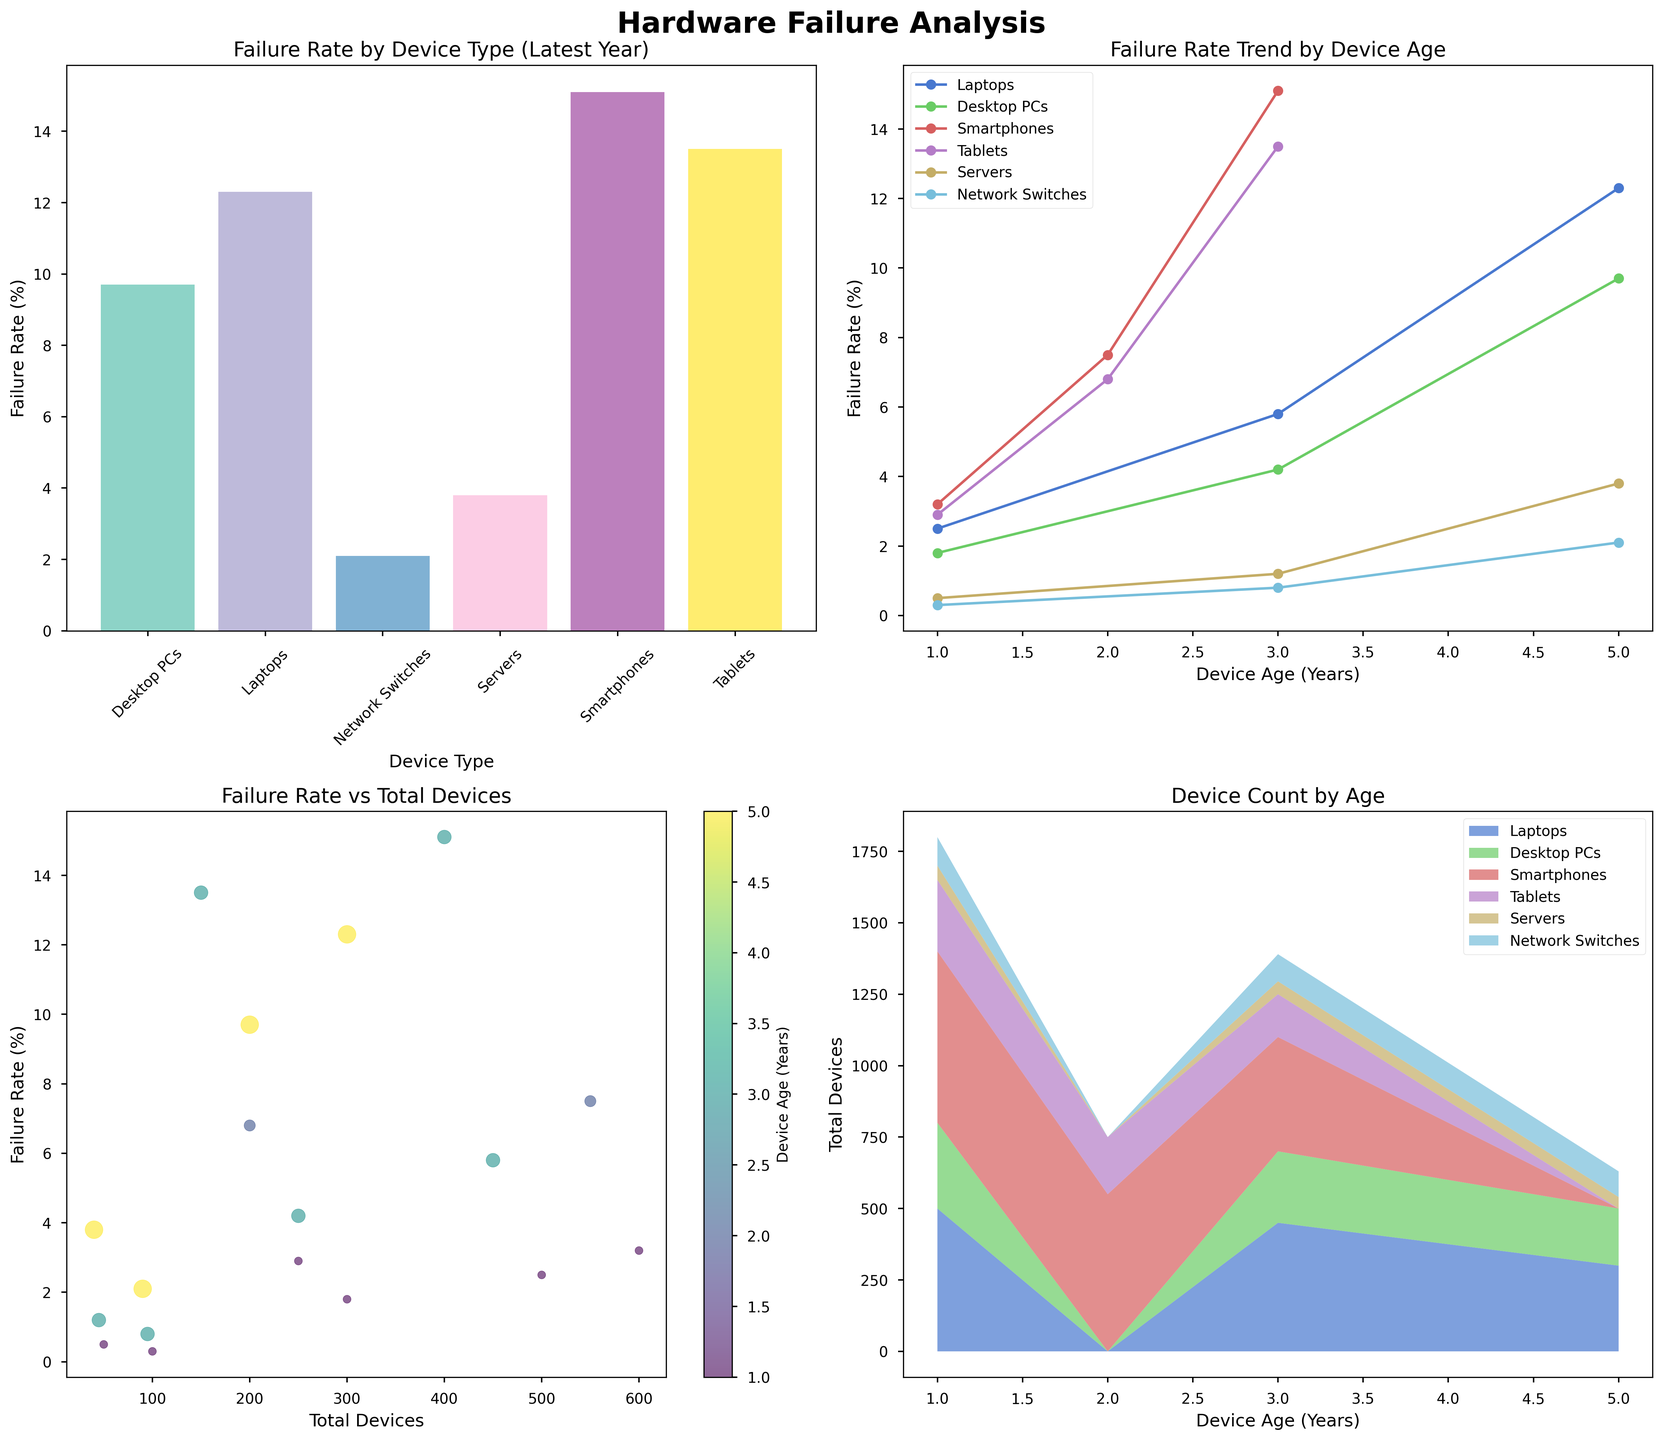What is the title of the bar plot in the top-left corner? The bar plot in the top-left corner of the figure has a title directly above it. You can observe the text "Failure Rate by Device Type (Latest Year)" written above the plot.
Answer: Failure Rate by Device Type (Latest Year) Which device type has the highest failure rate in the latest year according to the bar plot? The bar plot in the top-left corner depicts the failure rate by device type for the latest year. Among the devices, "Smartphones" has the tallest bar, indicating the highest failure rate.
Answer: Smartphones How does the failure rate trend change for Desktop PCs as the age increases according to the line plot? In the line plot in the top-right corner, the line representing Desktop PCs shows an upward trajectory from left to right, indicating that the failure rate increases as the age of Desktop PCs increases.
Answer: Increases What is the approximate failure rate of Network Switches when they are 5 years old as shown in the line plot? In the line plot in the top-right corner, locate the line corresponding to Network Switches. At the 5 years mark on the x-axis, the failure rate, denoted by a marker, is approximately 2.1%.
Answer: 2.1% Which subplot uses different colors to represent the age of the devices, and what kind of color scheme does it use? The scatter plot in the bottom-left corner uses a color gradient to represent the age of the devices. The color bar on the right side of this plot shows that it uses a viridis color scheme.
Answer: Scatter plot, viridis How do the total devices count change for Tablets as the age increases according to the stacked area plot? In the stacked area plot in the bottom-right corner, follow the area section corresponding to Tablets. This section of the plot diminishes in size as you move from left (age 1 year) to right (age 3 years), indicating a decrease in the total number of Tablets as they get older.
Answer: Decreases Compare the failure rate between Servers and Laptops at 5 years old according to the line plot. Which has a higher failure rate? In the line plot, observe the markers at 5 years for both Servers and Laptops. The marker for Laptops is significantly higher than that for Servers. Therefore, Laptops have a higher failure rate at 5 years old.
Answer: Laptops Among devices aged 1 year, which type has the second-lowest failure rate according to the scatter plot? In the scatter plot, examine the points at 1 year (color-coded according to the color bar). The lowest failure rate is for Network Switches, followed by Servers, which have the second-lowest failure rate for 1-year-old devices.
Answer: Servers What is the age range considered for the devices in the figure? The figure shows data for devices aged 1 year, 3 years, and 5 years. This can be confirmed by checking the x-axis labels in the line plot and the age legend in the scatter plot as well as the x-axis in the stacked area plot.
Answer: 1 to 5 years 